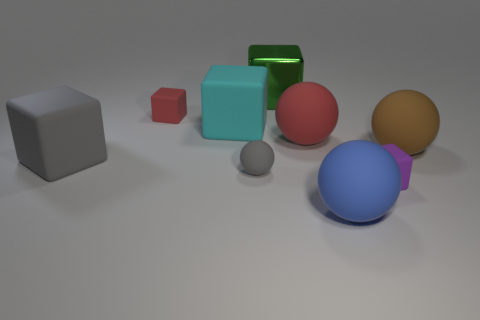Subtract all tiny gray matte spheres. How many spheres are left? 3 Subtract all brown spheres. How many spheres are left? 3 Subtract 3 blocks. How many blocks are left? 2 Add 8 cyan blocks. How many cyan blocks are left? 9 Add 5 gray matte balls. How many gray matte balls exist? 6 Subtract 0 red cylinders. How many objects are left? 9 Subtract all spheres. How many objects are left? 5 Subtract all gray cubes. Subtract all cyan cylinders. How many cubes are left? 4 Subtract all big gray cylinders. Subtract all red balls. How many objects are left? 8 